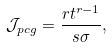<formula> <loc_0><loc_0><loc_500><loc_500>\mathcal { J } _ { p c g } = \frac { r t ^ { r - 1 } } { s \sigma } ,</formula> 